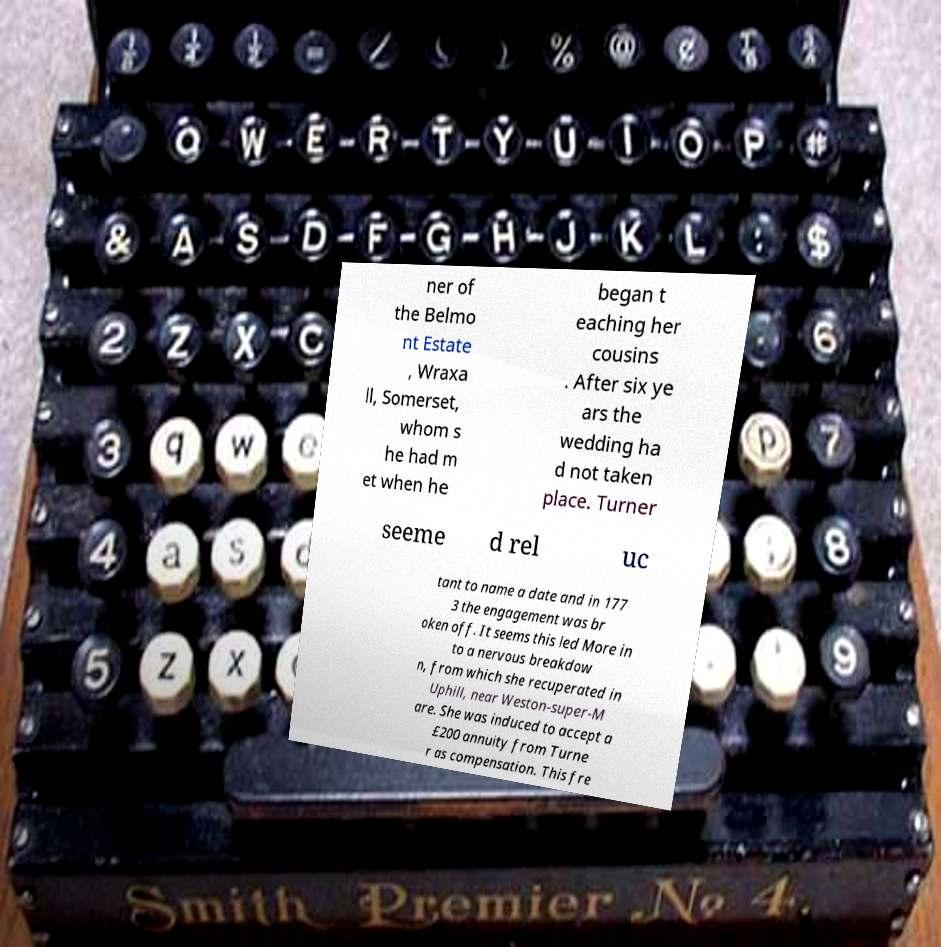For documentation purposes, I need the text within this image transcribed. Could you provide that? ner of the Belmo nt Estate , Wraxa ll, Somerset, whom s he had m et when he began t eaching her cousins . After six ye ars the wedding ha d not taken place. Turner seeme d rel uc tant to name a date and in 177 3 the engagement was br oken off. It seems this led More in to a nervous breakdow n, from which she recuperated in Uphill, near Weston-super-M are. She was induced to accept a £200 annuity from Turne r as compensation. This fre 